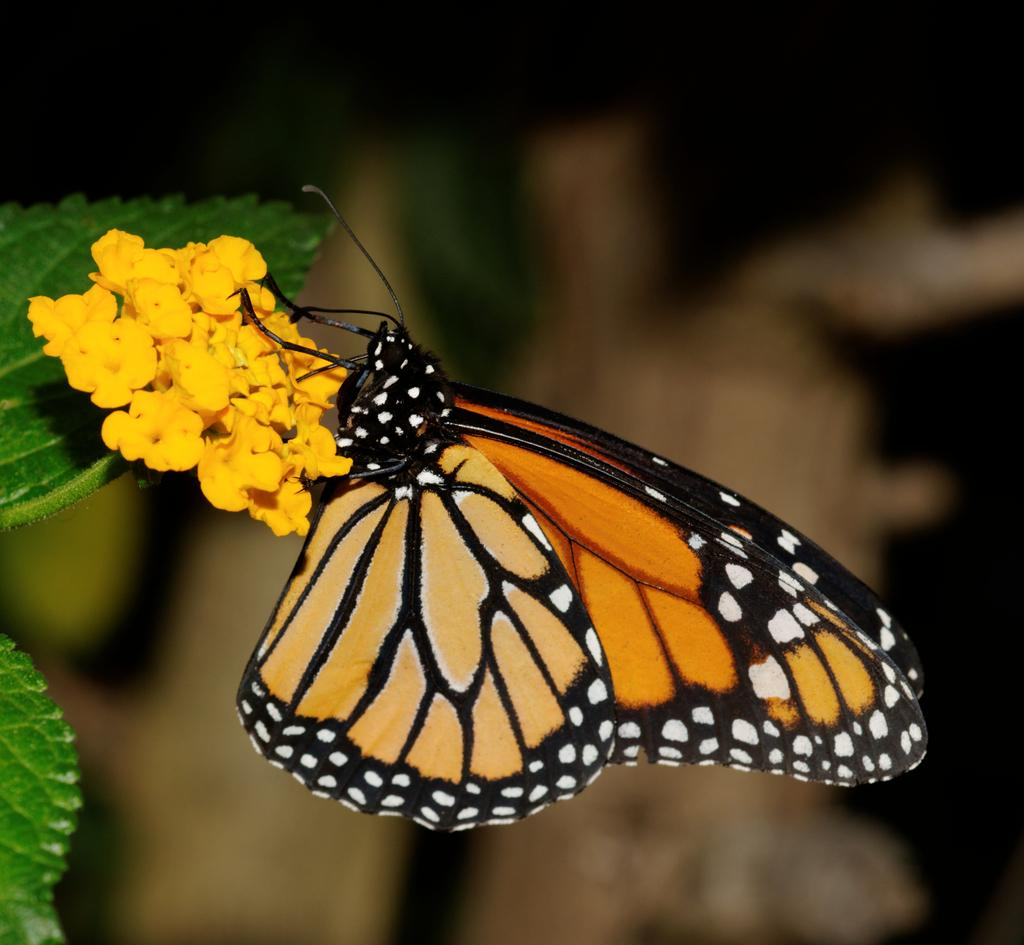What is the main subject of the image? The main subject of the image is a butterfly on a flower. What type of plant is visible on the left side of the image? There is a plant with leaves and flowers on the left side of the image. How would you describe the background of the image? The background of the image is blurry. What type of writing can be seen on the butterfly's wings in the image? There is no writing present on the butterfly's wings in the image. 